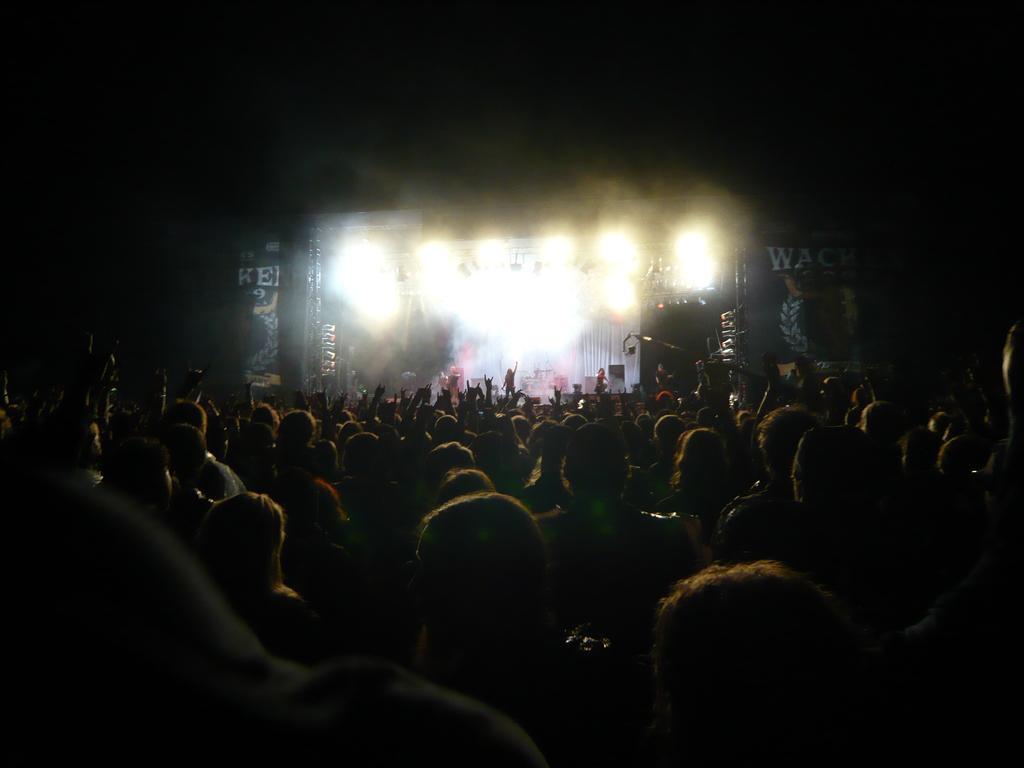In one or two sentences, can you explain what this image depicts? In the image in the center we can see one stage. On the stage,we can see one person standing. And we can see lights,banners,speakers and few other objects. In the bottom of the image,we can see a group of people were sitting. 